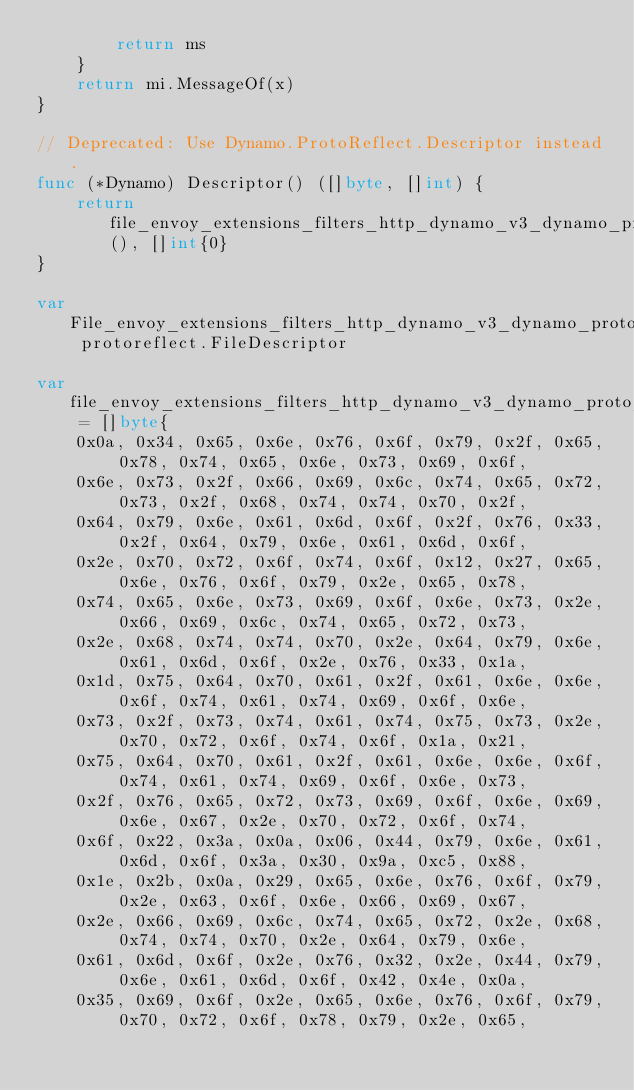Convert code to text. <code><loc_0><loc_0><loc_500><loc_500><_Go_>		return ms
	}
	return mi.MessageOf(x)
}

// Deprecated: Use Dynamo.ProtoReflect.Descriptor instead.
func (*Dynamo) Descriptor() ([]byte, []int) {
	return file_envoy_extensions_filters_http_dynamo_v3_dynamo_proto_rawDescGZIP(), []int{0}
}

var File_envoy_extensions_filters_http_dynamo_v3_dynamo_proto protoreflect.FileDescriptor

var file_envoy_extensions_filters_http_dynamo_v3_dynamo_proto_rawDesc = []byte{
	0x0a, 0x34, 0x65, 0x6e, 0x76, 0x6f, 0x79, 0x2f, 0x65, 0x78, 0x74, 0x65, 0x6e, 0x73, 0x69, 0x6f,
	0x6e, 0x73, 0x2f, 0x66, 0x69, 0x6c, 0x74, 0x65, 0x72, 0x73, 0x2f, 0x68, 0x74, 0x74, 0x70, 0x2f,
	0x64, 0x79, 0x6e, 0x61, 0x6d, 0x6f, 0x2f, 0x76, 0x33, 0x2f, 0x64, 0x79, 0x6e, 0x61, 0x6d, 0x6f,
	0x2e, 0x70, 0x72, 0x6f, 0x74, 0x6f, 0x12, 0x27, 0x65, 0x6e, 0x76, 0x6f, 0x79, 0x2e, 0x65, 0x78,
	0x74, 0x65, 0x6e, 0x73, 0x69, 0x6f, 0x6e, 0x73, 0x2e, 0x66, 0x69, 0x6c, 0x74, 0x65, 0x72, 0x73,
	0x2e, 0x68, 0x74, 0x74, 0x70, 0x2e, 0x64, 0x79, 0x6e, 0x61, 0x6d, 0x6f, 0x2e, 0x76, 0x33, 0x1a,
	0x1d, 0x75, 0x64, 0x70, 0x61, 0x2f, 0x61, 0x6e, 0x6e, 0x6f, 0x74, 0x61, 0x74, 0x69, 0x6f, 0x6e,
	0x73, 0x2f, 0x73, 0x74, 0x61, 0x74, 0x75, 0x73, 0x2e, 0x70, 0x72, 0x6f, 0x74, 0x6f, 0x1a, 0x21,
	0x75, 0x64, 0x70, 0x61, 0x2f, 0x61, 0x6e, 0x6e, 0x6f, 0x74, 0x61, 0x74, 0x69, 0x6f, 0x6e, 0x73,
	0x2f, 0x76, 0x65, 0x72, 0x73, 0x69, 0x6f, 0x6e, 0x69, 0x6e, 0x67, 0x2e, 0x70, 0x72, 0x6f, 0x74,
	0x6f, 0x22, 0x3a, 0x0a, 0x06, 0x44, 0x79, 0x6e, 0x61, 0x6d, 0x6f, 0x3a, 0x30, 0x9a, 0xc5, 0x88,
	0x1e, 0x2b, 0x0a, 0x29, 0x65, 0x6e, 0x76, 0x6f, 0x79, 0x2e, 0x63, 0x6f, 0x6e, 0x66, 0x69, 0x67,
	0x2e, 0x66, 0x69, 0x6c, 0x74, 0x65, 0x72, 0x2e, 0x68, 0x74, 0x74, 0x70, 0x2e, 0x64, 0x79, 0x6e,
	0x61, 0x6d, 0x6f, 0x2e, 0x76, 0x32, 0x2e, 0x44, 0x79, 0x6e, 0x61, 0x6d, 0x6f, 0x42, 0x4e, 0x0a,
	0x35, 0x69, 0x6f, 0x2e, 0x65, 0x6e, 0x76, 0x6f, 0x79, 0x70, 0x72, 0x6f, 0x78, 0x79, 0x2e, 0x65,</code> 